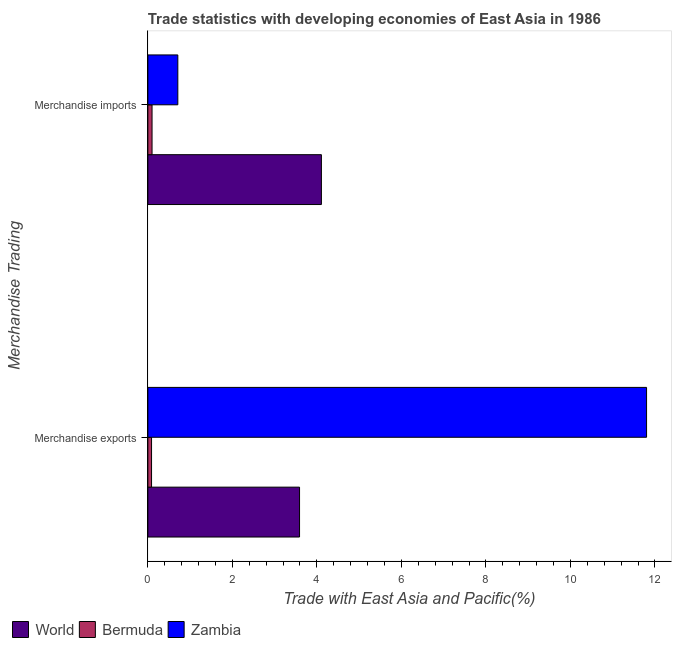What is the label of the 1st group of bars from the top?
Provide a succinct answer. Merchandise imports. What is the merchandise exports in Bermuda?
Give a very brief answer. 0.09. Across all countries, what is the maximum merchandise imports?
Your answer should be compact. 4.11. Across all countries, what is the minimum merchandise imports?
Your response must be concise. 0.1. In which country was the merchandise exports maximum?
Your answer should be very brief. Zambia. In which country was the merchandise imports minimum?
Provide a short and direct response. Bermuda. What is the total merchandise exports in the graph?
Give a very brief answer. 15.48. What is the difference between the merchandise exports in Zambia and that in World?
Provide a short and direct response. 8.21. What is the difference between the merchandise exports in Zambia and the merchandise imports in Bermuda?
Make the answer very short. 11.7. What is the average merchandise exports per country?
Make the answer very short. 5.16. What is the difference between the merchandise imports and merchandise exports in Zambia?
Provide a succinct answer. -11.09. In how many countries, is the merchandise exports greater than 2 %?
Your answer should be very brief. 2. What is the ratio of the merchandise exports in Bermuda to that in World?
Offer a very short reply. 0.02. Is the merchandise exports in Zambia less than that in World?
Your answer should be compact. No. In how many countries, is the merchandise imports greater than the average merchandise imports taken over all countries?
Provide a succinct answer. 1. What does the 3rd bar from the top in Merchandise imports represents?
Ensure brevity in your answer.  World. What does the 3rd bar from the bottom in Merchandise imports represents?
Keep it short and to the point. Zambia. How many bars are there?
Offer a very short reply. 6. Are all the bars in the graph horizontal?
Your answer should be very brief. Yes. What is the difference between two consecutive major ticks on the X-axis?
Provide a short and direct response. 2. Are the values on the major ticks of X-axis written in scientific E-notation?
Provide a short and direct response. No. Does the graph contain grids?
Your answer should be very brief. No. How many legend labels are there?
Your response must be concise. 3. What is the title of the graph?
Offer a very short reply. Trade statistics with developing economies of East Asia in 1986. What is the label or title of the X-axis?
Provide a short and direct response. Trade with East Asia and Pacific(%). What is the label or title of the Y-axis?
Offer a very short reply. Merchandise Trading. What is the Trade with East Asia and Pacific(%) of World in Merchandise exports?
Give a very brief answer. 3.59. What is the Trade with East Asia and Pacific(%) of Bermuda in Merchandise exports?
Keep it short and to the point. 0.09. What is the Trade with East Asia and Pacific(%) in Zambia in Merchandise exports?
Offer a terse response. 11.8. What is the Trade with East Asia and Pacific(%) of World in Merchandise imports?
Your answer should be compact. 4.11. What is the Trade with East Asia and Pacific(%) in Bermuda in Merchandise imports?
Ensure brevity in your answer.  0.1. What is the Trade with East Asia and Pacific(%) of Zambia in Merchandise imports?
Keep it short and to the point. 0.71. Across all Merchandise Trading, what is the maximum Trade with East Asia and Pacific(%) in World?
Your response must be concise. 4.11. Across all Merchandise Trading, what is the maximum Trade with East Asia and Pacific(%) of Bermuda?
Your answer should be very brief. 0.1. Across all Merchandise Trading, what is the maximum Trade with East Asia and Pacific(%) in Zambia?
Your response must be concise. 11.8. Across all Merchandise Trading, what is the minimum Trade with East Asia and Pacific(%) in World?
Provide a succinct answer. 3.59. Across all Merchandise Trading, what is the minimum Trade with East Asia and Pacific(%) in Bermuda?
Provide a succinct answer. 0.09. Across all Merchandise Trading, what is the minimum Trade with East Asia and Pacific(%) of Zambia?
Your answer should be very brief. 0.71. What is the total Trade with East Asia and Pacific(%) of World in the graph?
Offer a very short reply. 7.7. What is the total Trade with East Asia and Pacific(%) in Bermuda in the graph?
Keep it short and to the point. 0.19. What is the total Trade with East Asia and Pacific(%) of Zambia in the graph?
Keep it short and to the point. 12.51. What is the difference between the Trade with East Asia and Pacific(%) of World in Merchandise exports and that in Merchandise imports?
Give a very brief answer. -0.52. What is the difference between the Trade with East Asia and Pacific(%) in Bermuda in Merchandise exports and that in Merchandise imports?
Offer a very short reply. -0.01. What is the difference between the Trade with East Asia and Pacific(%) of Zambia in Merchandise exports and that in Merchandise imports?
Offer a very short reply. 11.09. What is the difference between the Trade with East Asia and Pacific(%) of World in Merchandise exports and the Trade with East Asia and Pacific(%) of Bermuda in Merchandise imports?
Provide a succinct answer. 3.49. What is the difference between the Trade with East Asia and Pacific(%) of World in Merchandise exports and the Trade with East Asia and Pacific(%) of Zambia in Merchandise imports?
Keep it short and to the point. 2.88. What is the difference between the Trade with East Asia and Pacific(%) of Bermuda in Merchandise exports and the Trade with East Asia and Pacific(%) of Zambia in Merchandise imports?
Provide a succinct answer. -0.62. What is the average Trade with East Asia and Pacific(%) in World per Merchandise Trading?
Your response must be concise. 3.85. What is the average Trade with East Asia and Pacific(%) of Bermuda per Merchandise Trading?
Provide a succinct answer. 0.09. What is the average Trade with East Asia and Pacific(%) of Zambia per Merchandise Trading?
Make the answer very short. 6.26. What is the difference between the Trade with East Asia and Pacific(%) of World and Trade with East Asia and Pacific(%) of Bermuda in Merchandise exports?
Your response must be concise. 3.5. What is the difference between the Trade with East Asia and Pacific(%) in World and Trade with East Asia and Pacific(%) in Zambia in Merchandise exports?
Give a very brief answer. -8.21. What is the difference between the Trade with East Asia and Pacific(%) in Bermuda and Trade with East Asia and Pacific(%) in Zambia in Merchandise exports?
Your answer should be compact. -11.71. What is the difference between the Trade with East Asia and Pacific(%) in World and Trade with East Asia and Pacific(%) in Bermuda in Merchandise imports?
Provide a succinct answer. 4.01. What is the difference between the Trade with East Asia and Pacific(%) of World and Trade with East Asia and Pacific(%) of Zambia in Merchandise imports?
Ensure brevity in your answer.  3.4. What is the difference between the Trade with East Asia and Pacific(%) in Bermuda and Trade with East Asia and Pacific(%) in Zambia in Merchandise imports?
Your answer should be very brief. -0.61. What is the ratio of the Trade with East Asia and Pacific(%) in World in Merchandise exports to that in Merchandise imports?
Your answer should be very brief. 0.87. What is the ratio of the Trade with East Asia and Pacific(%) of Bermuda in Merchandise exports to that in Merchandise imports?
Offer a very short reply. 0.88. What is the ratio of the Trade with East Asia and Pacific(%) of Zambia in Merchandise exports to that in Merchandise imports?
Keep it short and to the point. 16.65. What is the difference between the highest and the second highest Trade with East Asia and Pacific(%) of World?
Make the answer very short. 0.52. What is the difference between the highest and the second highest Trade with East Asia and Pacific(%) in Bermuda?
Make the answer very short. 0.01. What is the difference between the highest and the second highest Trade with East Asia and Pacific(%) of Zambia?
Offer a terse response. 11.09. What is the difference between the highest and the lowest Trade with East Asia and Pacific(%) in World?
Give a very brief answer. 0.52. What is the difference between the highest and the lowest Trade with East Asia and Pacific(%) in Bermuda?
Your answer should be very brief. 0.01. What is the difference between the highest and the lowest Trade with East Asia and Pacific(%) in Zambia?
Keep it short and to the point. 11.09. 